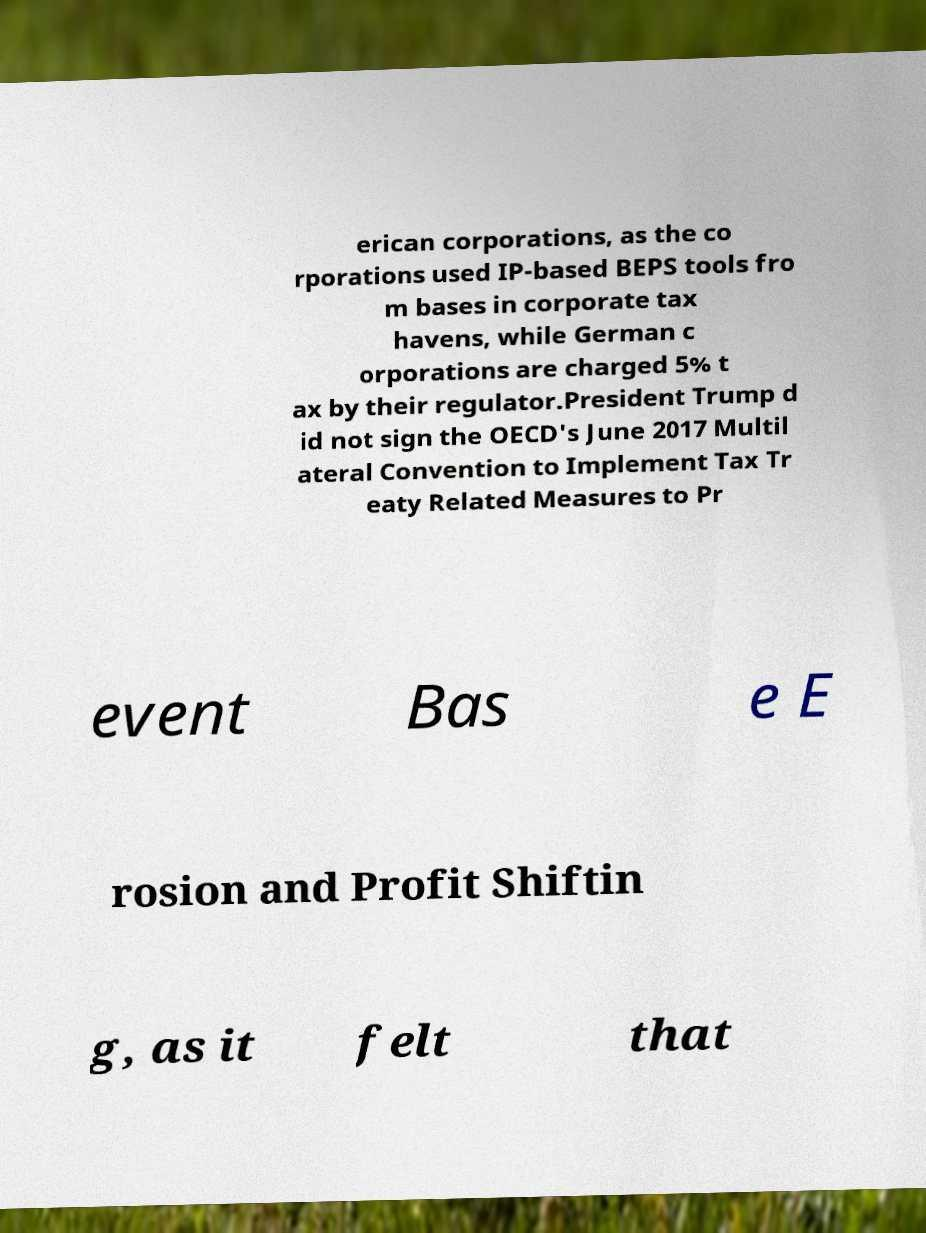I need the written content from this picture converted into text. Can you do that? erican corporations, as the co rporations used IP-based BEPS tools fro m bases in corporate tax havens, while German c orporations are charged 5% t ax by their regulator.President Trump d id not sign the OECD's June 2017 Multil ateral Convention to Implement Tax Tr eaty Related Measures to Pr event Bas e E rosion and Profit Shiftin g, as it felt that 